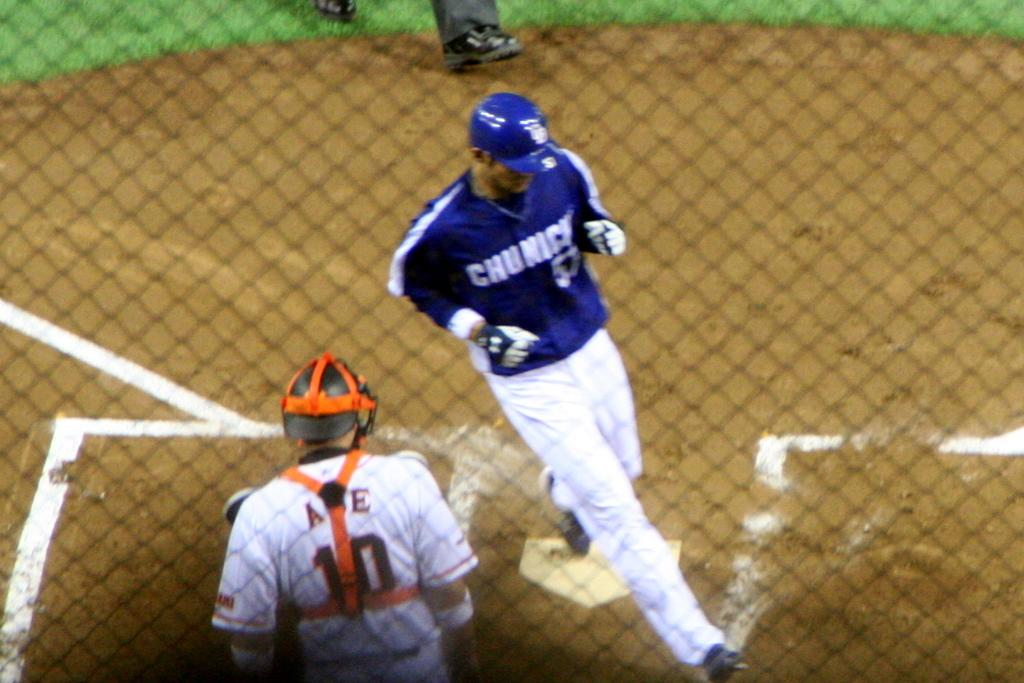<image>
Summarize the visual content of the image. Man wearing a blue jersey which says Chunnick on it. 